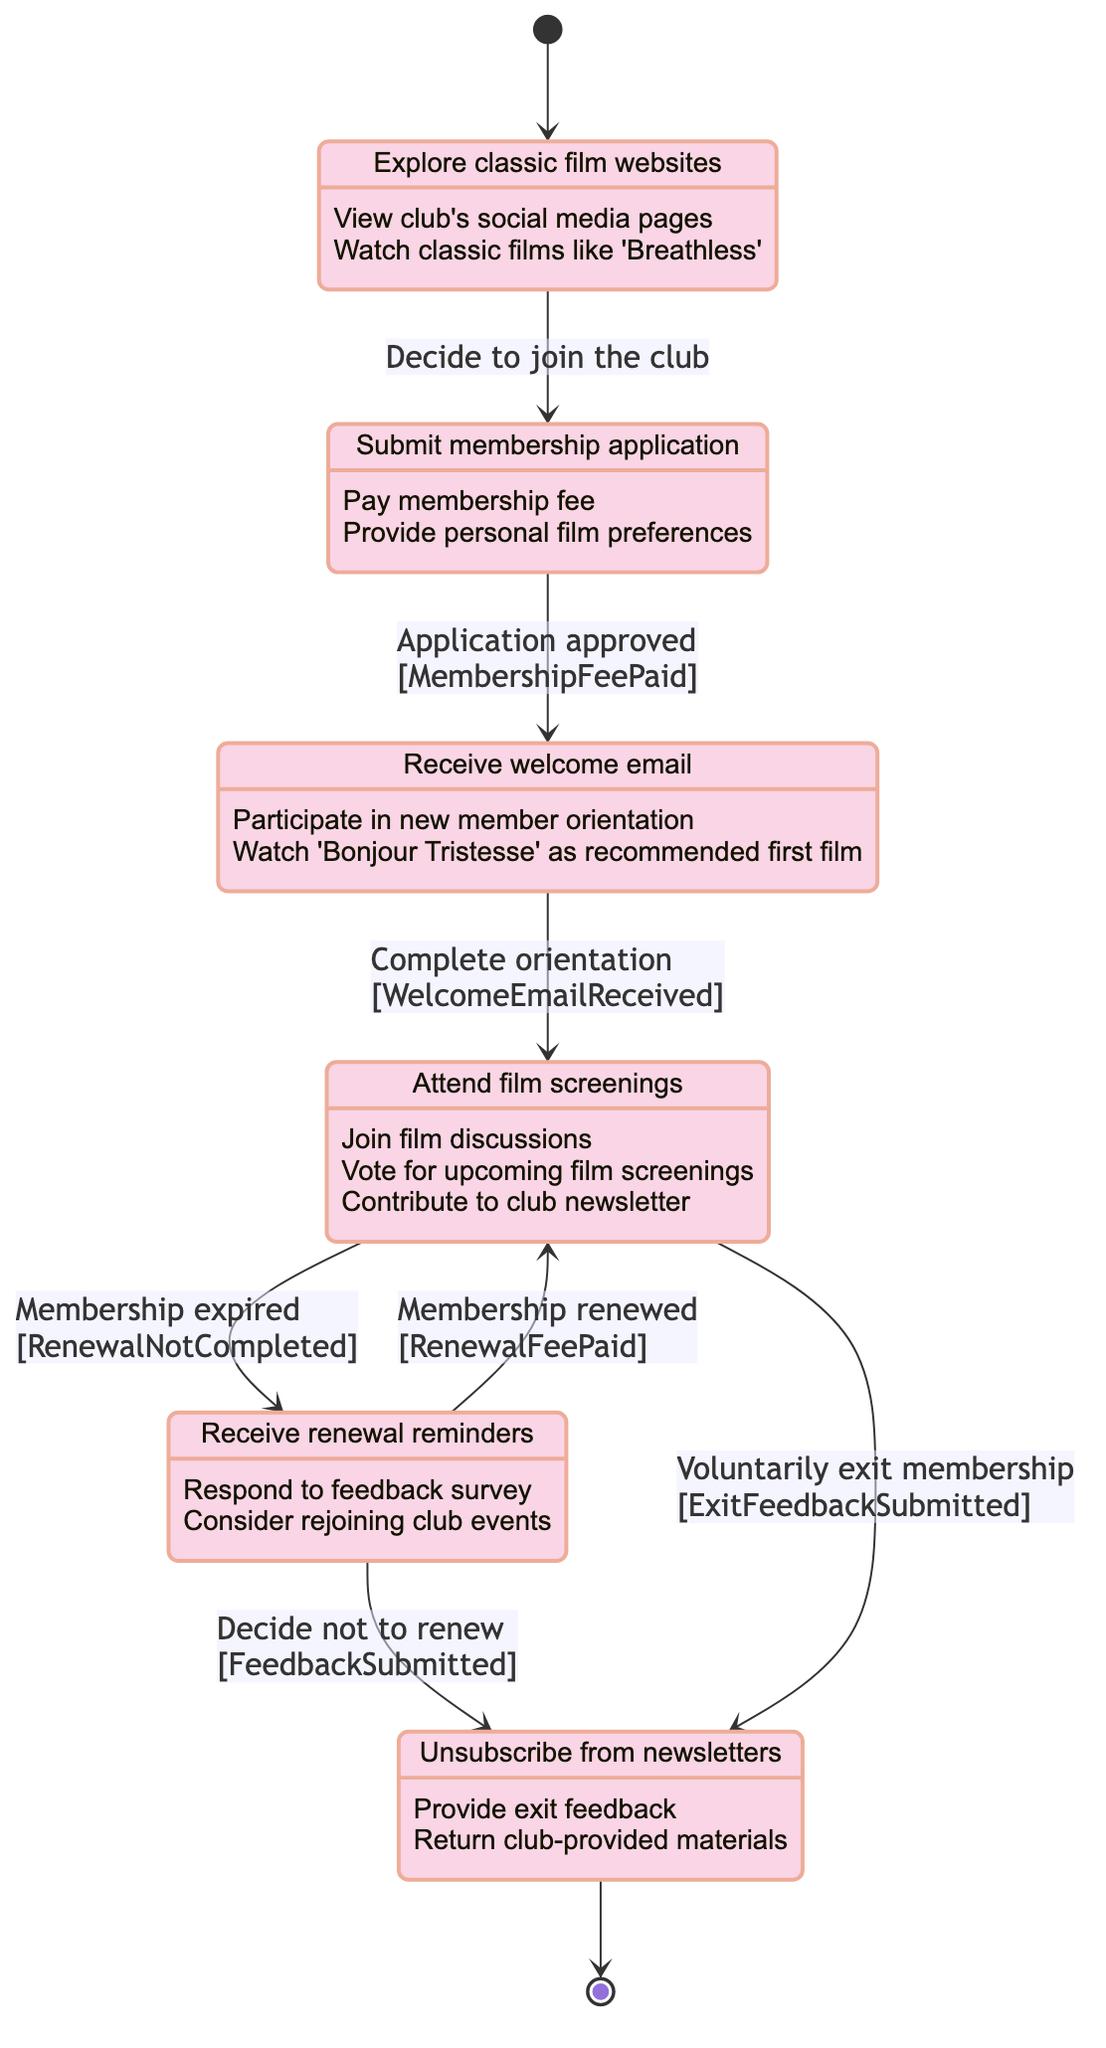What is the first state a person enters when they show interest in the club? The diagram indicates that the first state is "ProspectiveMember," which represents those exploring the club or classic films.
Answer: ProspectiveMember How many total states are represented in the diagram? There are six states outlined in the diagram: "ProspectiveMember," "ApplyingMember," "NewMember," "ActiveMember," "LapsedMember," and "ExitedMember."
Answer: 6 What activity is associated with the "ApplyingMember" state? The diagram lists specific activities for "ApplyingMember," including submitting a membership application.
Answer: Submit membership application Which state transitions to "NewMember"? The transition to "NewMember" occurs from "ApplyingMember" when the application is approved, contingent upon the membership fee being paid.
Answer: ApplyingMember How do members transition from "LapsedMember" back to "ActiveMember"? Members move back to "ActiveMember" from "LapsedMember" specifically when they renew their membership and pay the renewal fee.
Answer: Membership renewed What triggers the transition from "ActiveMember" to "ExitedMember"? The transition from "ActiveMember" to "ExitedMember" is triggered when a member voluntarily decides to exit their membership.
Answer: Voluntarily exit membership What is the guard condition for transitioning from "ApplyingMember" to "NewMember"? The guard condition that must be satisfied for this transition is that the membership fee must be paid.
Answer: MembershipFeePaid What activities do "ActiveMembers" participate in? "ActiveMembers" are involved in attending film screenings, joining discussions, voting for screenings, and contributing to the newsletter.
Answer: Attend film screenings, Join film discussions, Vote for upcoming film screenings, Contribute to club newsletter What happens to "ExitedMembers"? "ExitedMembers" typically unsubscribe from newsletters and might provide exit feedback or return club-provided materials after deciding to leave.
Answer: Unsubscribe from newsletters 